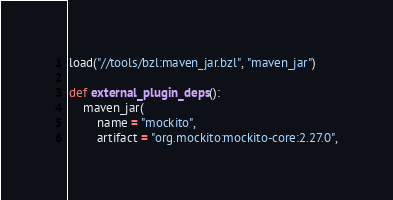<code> <loc_0><loc_0><loc_500><loc_500><_Python_>load("//tools/bzl:maven_jar.bzl", "maven_jar")

def external_plugin_deps():
    maven_jar(
        name = "mockito",
        artifact = "org.mockito:mockito-core:2.27.0",</code> 